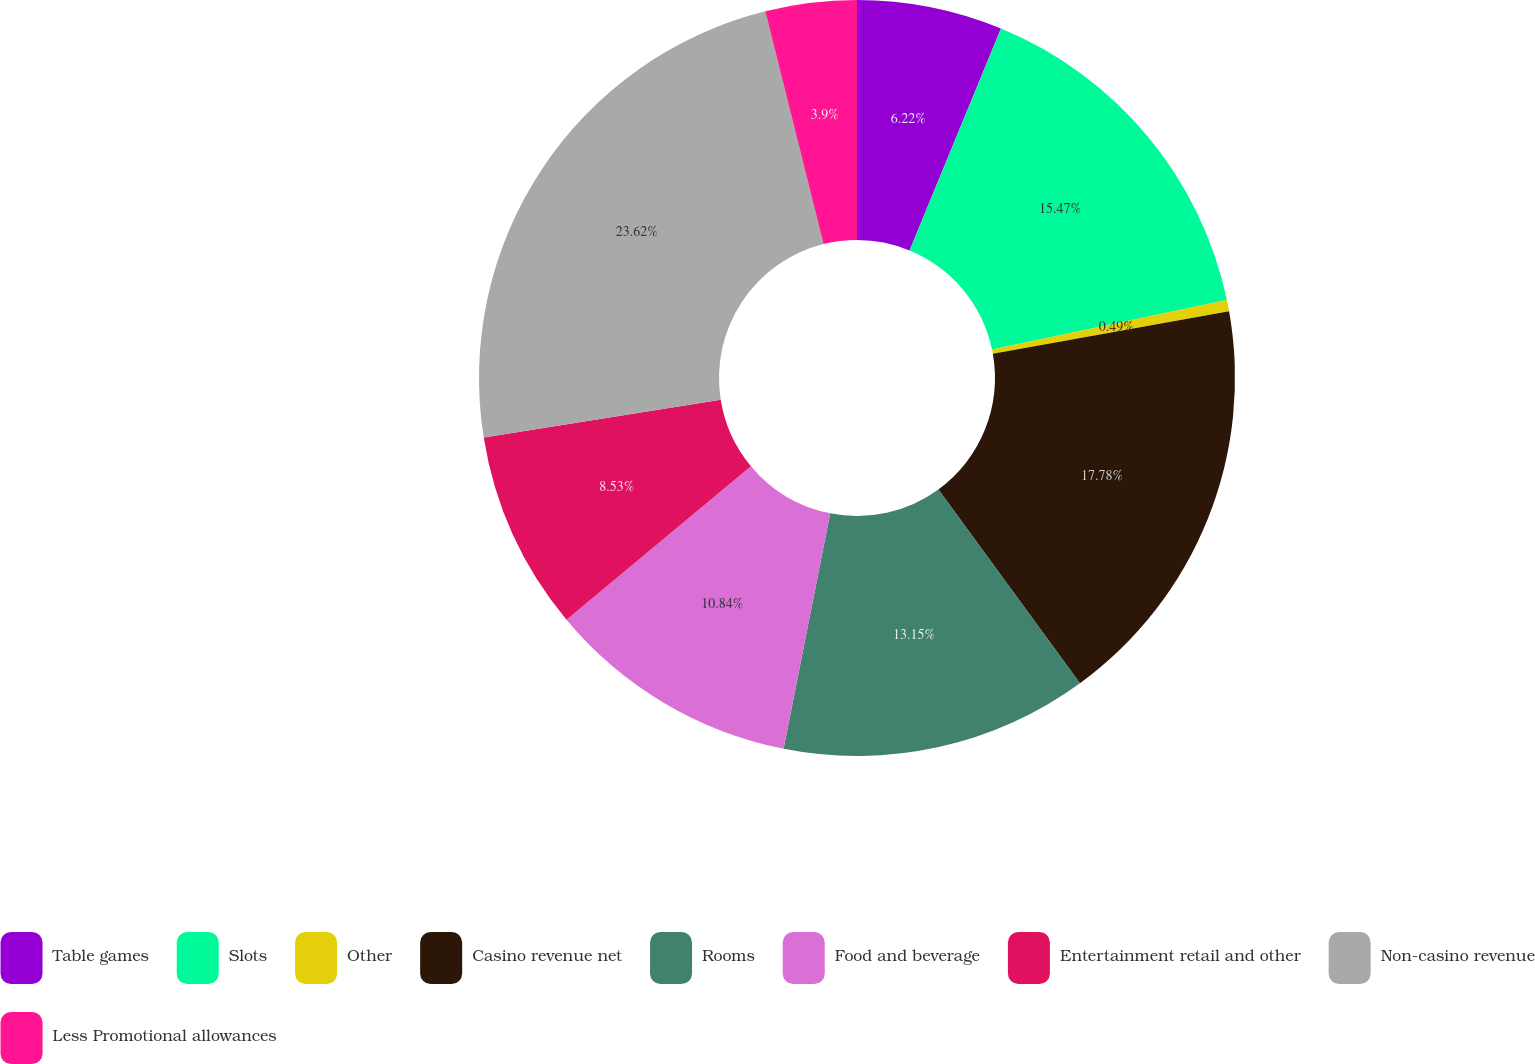Convert chart to OTSL. <chart><loc_0><loc_0><loc_500><loc_500><pie_chart><fcel>Table games<fcel>Slots<fcel>Other<fcel>Casino revenue net<fcel>Rooms<fcel>Food and beverage<fcel>Entertainment retail and other<fcel>Non-casino revenue<fcel>Less Promotional allowances<nl><fcel>6.22%<fcel>15.47%<fcel>0.49%<fcel>17.78%<fcel>13.15%<fcel>10.84%<fcel>8.53%<fcel>23.62%<fcel>3.9%<nl></chart> 